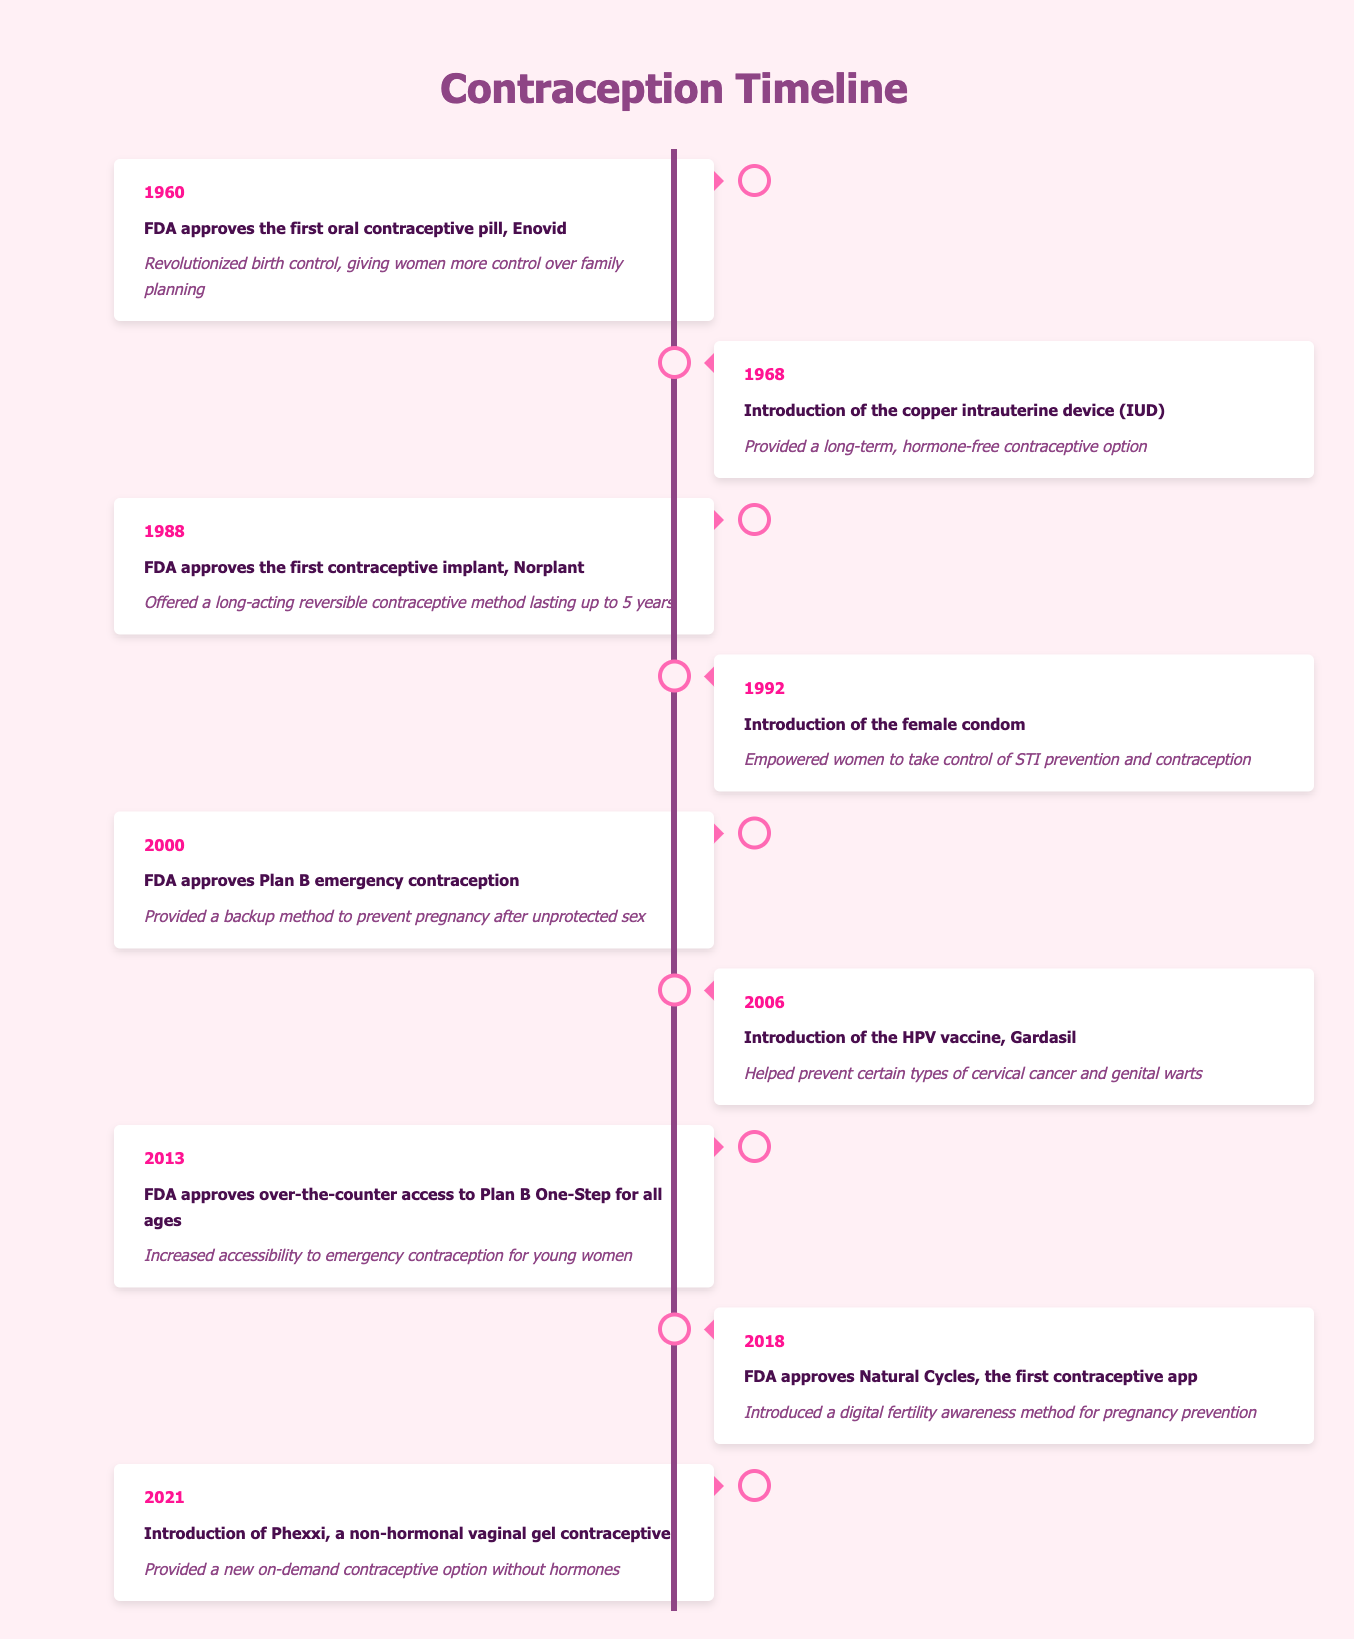What year was the first oral contraceptive approved? The table states that the first oral contraceptive pill, Enovid, was approved by the FDA in 1960.
Answer: 1960 What is the significance of the introduction of the female condom in 1992? According to the table, the significance of the female condom's introduction is that it empowered women to take control of STI prevention and contraception.
Answer: Empowerment for STI prevention and contraception How many years passed between the approval of Enovid and the introduction of Plan B? Enovid was approved in 1960 and Plan B was approved in 2000. The difference is 2000 - 1960 = 40 years.
Answer: 40 years Was the copper intrauterine device introduced before or after 1980? The table indicates that the copper IUD was introduced in 1968, which is before 1980.
Answer: Before 1980 What is the common theme of contraceptives introduced between 2000 and 2021? From the table, the contraceptives introduced during this period (Plan B, HPV vaccine, Plan B One-Step access, Natural Cycles, and Phexxi) focus on increasing accessibility and options without hormones, indicating a move towards diverse and accessible contraceptive methods. This includes emergency contraception and digital methods.
Answer: Increasing accessibility and diverse options What is the difference in years between the introduction of the first contraceptive implant and the first contraceptive app? The table shows the first contraceptive implant (Norplant) was approved in 1988 and the first contraceptive app (Natural Cycles) was approved in 2018. The difference is 2018 - 1988 = 30 years.
Answer: 30 years Did the introduction of Gardasil in 2006 relate to contraception directly? The table mentions that Gardasil helped prevent certain types of cervical cancer and genital warts, which is related to sexual health but not directly a contraceptive method. Therefore, it is not primarily about contraception.
Answer: No What were the new types of contraceptive methods introduced between 1968 and 2021? Reviewing the table, the new types include the copper IUD in 1968, the contraceptive implant in 1988, the female condom in 1992, Plan B in 2000, Gardasil in 2006, over-the-counter Plan B in 2013, the contraceptive app in 2018, and Phexxi in 2021.
Answer: Eight new types Explain the significance of the 2013 FDA decision regarding Plan B One-Step. The table states that the FDA's approval for over-the-counter access to Plan B One-Step in 2013 increased accessibility to emergency contraception for young women. This decision enabled young women to obtain emergency contraception without a prescription, highlighting a significant step towards reproductive autonomy.
Answer: Increased accessibility for young women 